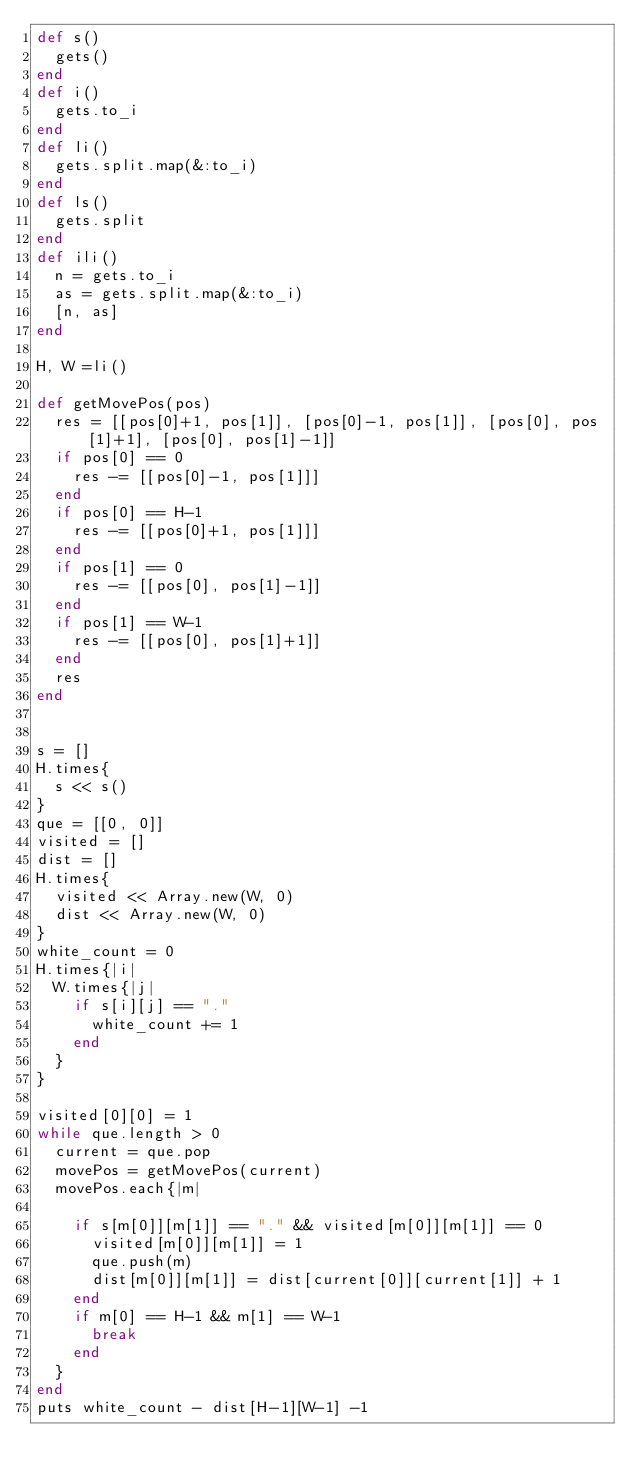Convert code to text. <code><loc_0><loc_0><loc_500><loc_500><_Ruby_>def s()
  gets()
end
def i()
  gets.to_i
end
def li()
  gets.split.map(&:to_i)
end
def ls()
  gets.split
end
def ili()
  n = gets.to_i
  as = gets.split.map(&:to_i)
  [n, as]
end

H, W =li()

def getMovePos(pos)
  res = [[pos[0]+1, pos[1]], [pos[0]-1, pos[1]], [pos[0], pos[1]+1], [pos[0], pos[1]-1]]
  if pos[0] == 0
    res -= [[pos[0]-1, pos[1]]]
  end
  if pos[0] == H-1
    res -= [[pos[0]+1, pos[1]]]
  end
  if pos[1] == 0
    res -= [[pos[0], pos[1]-1]]
  end
  if pos[1] == W-1
    res -= [[pos[0], pos[1]+1]]
  end
  res
end


s = []
H.times{
  s << s()
}
que = [[0, 0]]
visited = []
dist = []
H.times{
  visited << Array.new(W, 0)
  dist << Array.new(W, 0)
}
white_count = 0
H.times{|i|
  W.times{|j|
    if s[i][j] == "."
      white_count += 1
    end
  }
}

visited[0][0] = 1
while que.length > 0
  current = que.pop
  movePos = getMovePos(current)
  movePos.each{|m|

    if s[m[0]][m[1]] == "." && visited[m[0]][m[1]] == 0
      visited[m[0]][m[1]] = 1
      que.push(m)
      dist[m[0]][m[1]] = dist[current[0]][current[1]] + 1
    end
    if m[0] == H-1 && m[1] == W-1
      break
    end
  }
end
puts white_count - dist[H-1][W-1] -1


</code> 